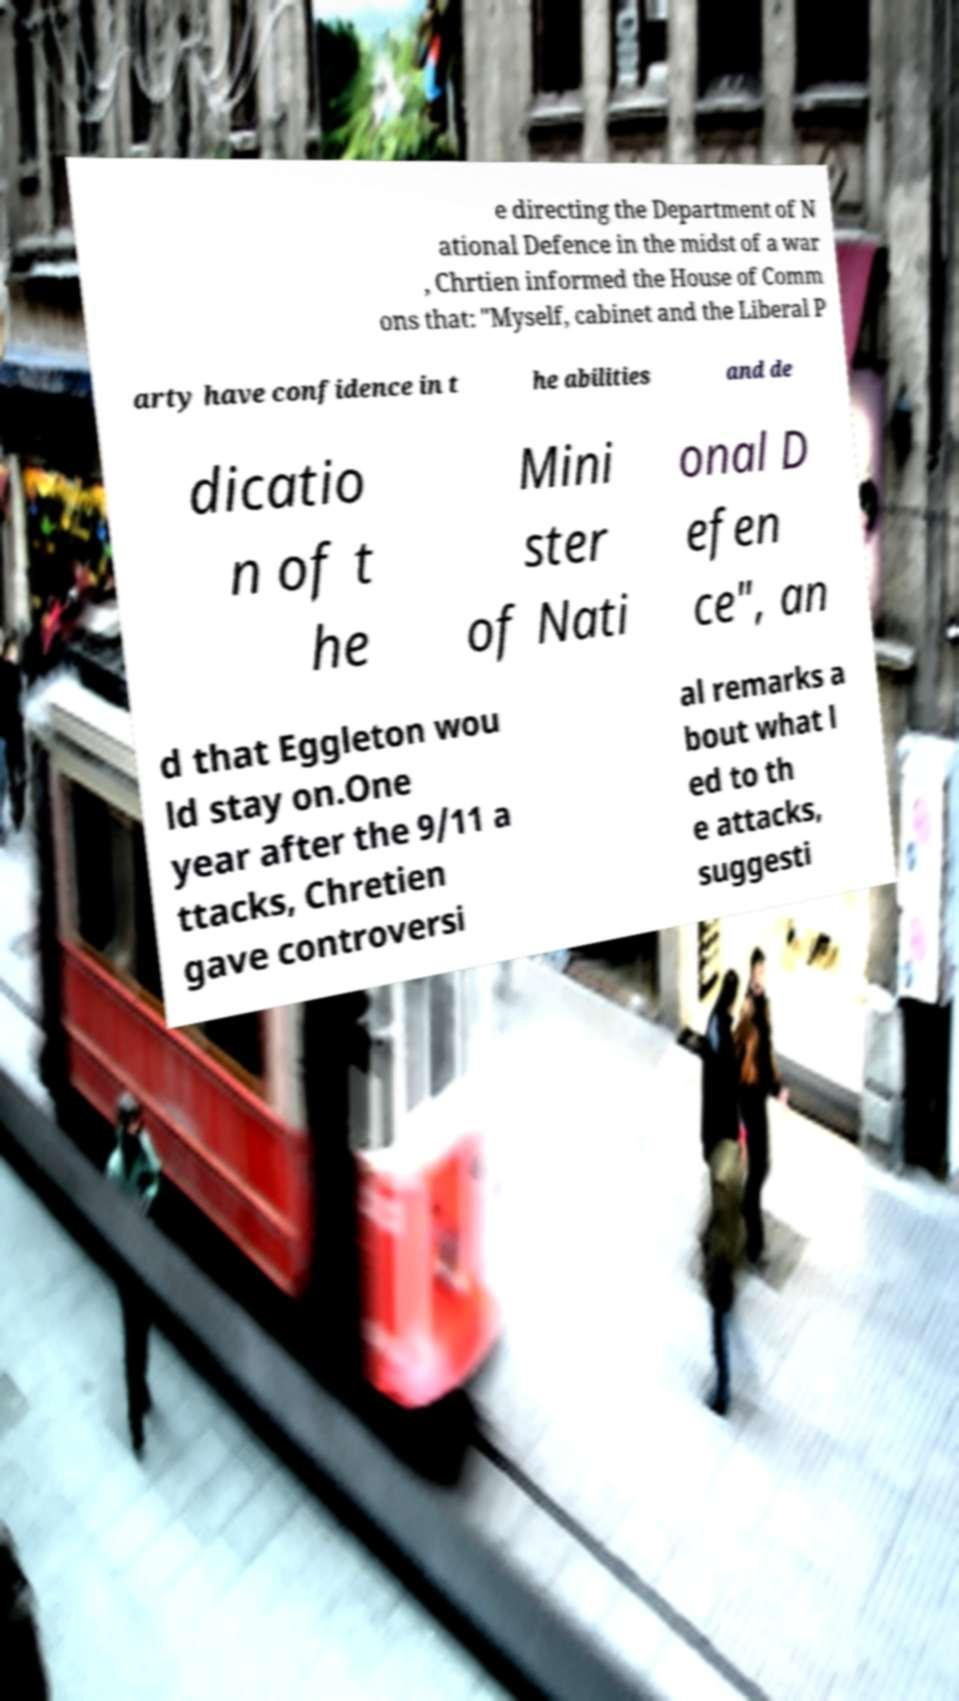Can you accurately transcribe the text from the provided image for me? e directing the Department of N ational Defence in the midst of a war , Chrtien informed the House of Comm ons that: "Myself, cabinet and the Liberal P arty have confidence in t he abilities and de dicatio n of t he Mini ster of Nati onal D efen ce", an d that Eggleton wou ld stay on.One year after the 9/11 a ttacks, Chretien gave controversi al remarks a bout what l ed to th e attacks, suggesti 